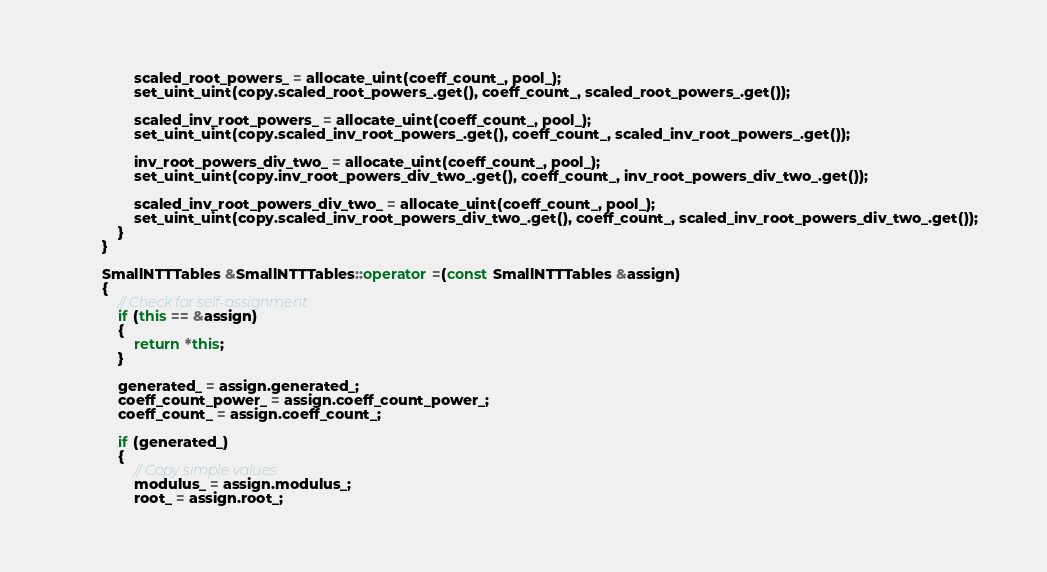<code> <loc_0><loc_0><loc_500><loc_500><_C++_>                scaled_root_powers_ = allocate_uint(coeff_count_, pool_);
                set_uint_uint(copy.scaled_root_powers_.get(), coeff_count_, scaled_root_powers_.get());

                scaled_inv_root_powers_ = allocate_uint(coeff_count_, pool_);
                set_uint_uint(copy.scaled_inv_root_powers_.get(), coeff_count_, scaled_inv_root_powers_.get());

                inv_root_powers_div_two_ = allocate_uint(coeff_count_, pool_);
                set_uint_uint(copy.inv_root_powers_div_two_.get(), coeff_count_, inv_root_powers_div_two_.get());

                scaled_inv_root_powers_div_two_ = allocate_uint(coeff_count_, pool_);
                set_uint_uint(copy.scaled_inv_root_powers_div_two_.get(), coeff_count_, scaled_inv_root_powers_div_two_.get());
            }
        }
        
        SmallNTTTables &SmallNTTTables::operator =(const SmallNTTTables &assign)
        {
            // Check for self-assignment
            if (this == &assign)
            {
                return *this;
            }

            generated_ = assign.generated_;
            coeff_count_power_ = assign.coeff_count_power_;
            coeff_count_ = assign.coeff_count_;

            if (generated_)
            {
                // Copy simple values
                modulus_ = assign.modulus_;
                root_ = assign.root_;</code> 